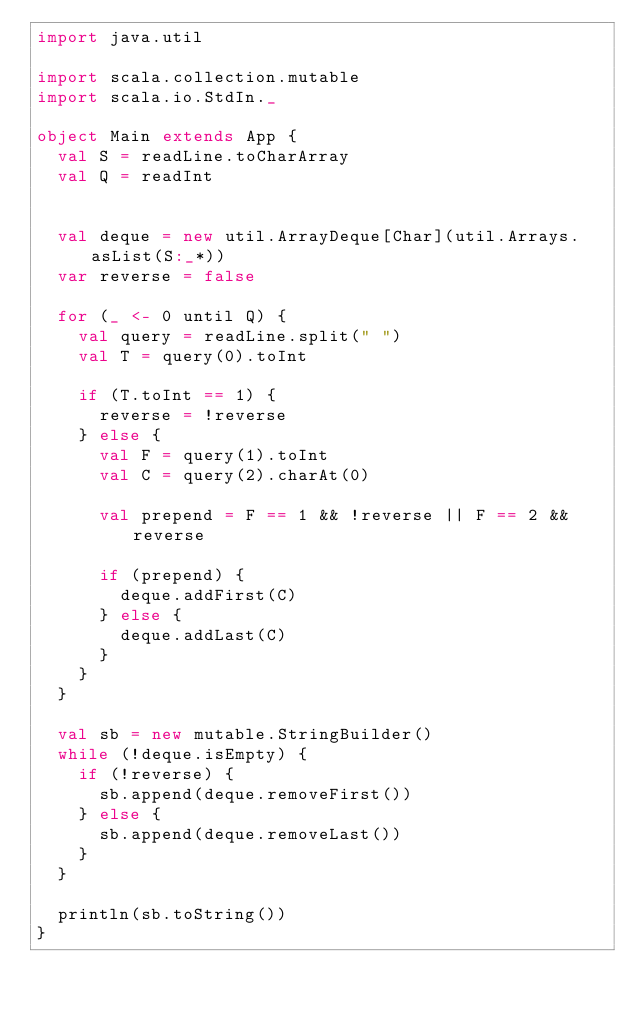Convert code to text. <code><loc_0><loc_0><loc_500><loc_500><_Scala_>import java.util

import scala.collection.mutable
import scala.io.StdIn._

object Main extends App {
  val S = readLine.toCharArray
  val Q = readInt


  val deque = new util.ArrayDeque[Char](util.Arrays.asList(S:_*))
  var reverse = false

  for (_ <- 0 until Q) {
    val query = readLine.split(" ")
    val T = query(0).toInt

    if (T.toInt == 1) {
      reverse = !reverse
    } else {
      val F = query(1).toInt
      val C = query(2).charAt(0)

      val prepend = F == 1 && !reverse || F == 2 && reverse

      if (prepend) {
        deque.addFirst(C)
      } else {
        deque.addLast(C)
      }
    }
  }

  val sb = new mutable.StringBuilder()
  while (!deque.isEmpty) {
    if (!reverse) {
      sb.append(deque.removeFirst())
    } else {
      sb.append(deque.removeLast())
    }
  }

  println(sb.toString())
}


</code> 